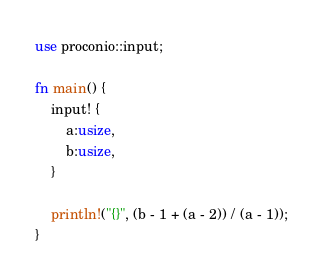Convert code to text. <code><loc_0><loc_0><loc_500><loc_500><_Rust_>use proconio::input;

fn main() {
    input! {
        a:usize,
        b:usize,
    }

    println!("{}", (b - 1 + (a - 2)) / (a - 1));
}
</code> 